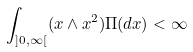<formula> <loc_0><loc_0><loc_500><loc_500>\int _ { ] 0 , \infty [ } ( x \wedge x ^ { 2 } ) \Pi ( d x ) < \infty</formula> 